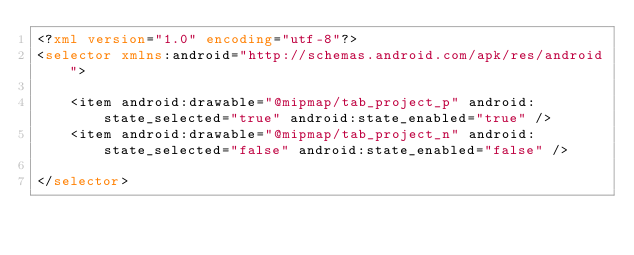<code> <loc_0><loc_0><loc_500><loc_500><_XML_><?xml version="1.0" encoding="utf-8"?>
<selector xmlns:android="http://schemas.android.com/apk/res/android">

    <item android:drawable="@mipmap/tab_project_p" android:state_selected="true" android:state_enabled="true" />
    <item android:drawable="@mipmap/tab_project_n" android:state_selected="false" android:state_enabled="false" />

</selector></code> 